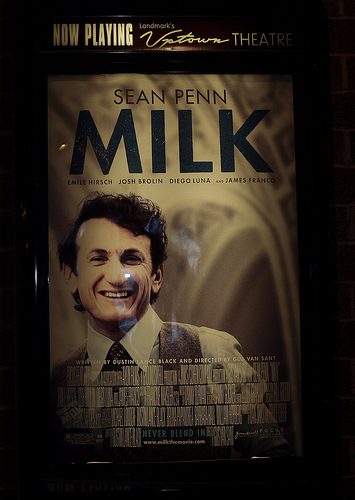<image>
Can you confirm if the milk is above the man? Yes. The milk is positioned above the man in the vertical space, higher up in the scene. 